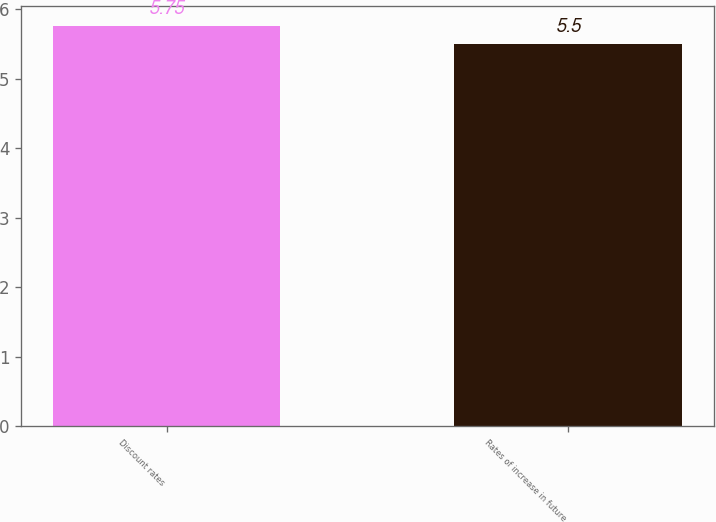<chart> <loc_0><loc_0><loc_500><loc_500><bar_chart><fcel>Discount rates<fcel>Rates of increase in future<nl><fcel>5.75<fcel>5.5<nl></chart> 